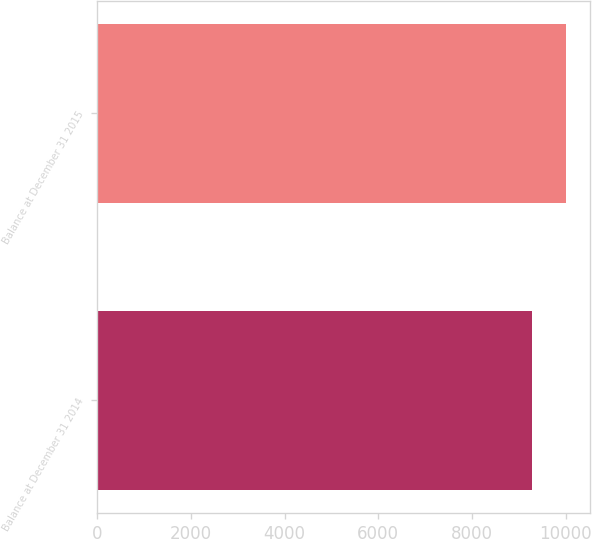Convert chart. <chart><loc_0><loc_0><loc_500><loc_500><bar_chart><fcel>Balance at December 31 2014<fcel>Balance at December 31 2015<nl><fcel>9284<fcel>10019<nl></chart> 